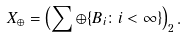<formula> <loc_0><loc_0><loc_500><loc_500>X _ { \oplus } = \left ( \sum \oplus \{ B _ { i } \colon i < \infty \} \right ) _ { 2 } .</formula> 